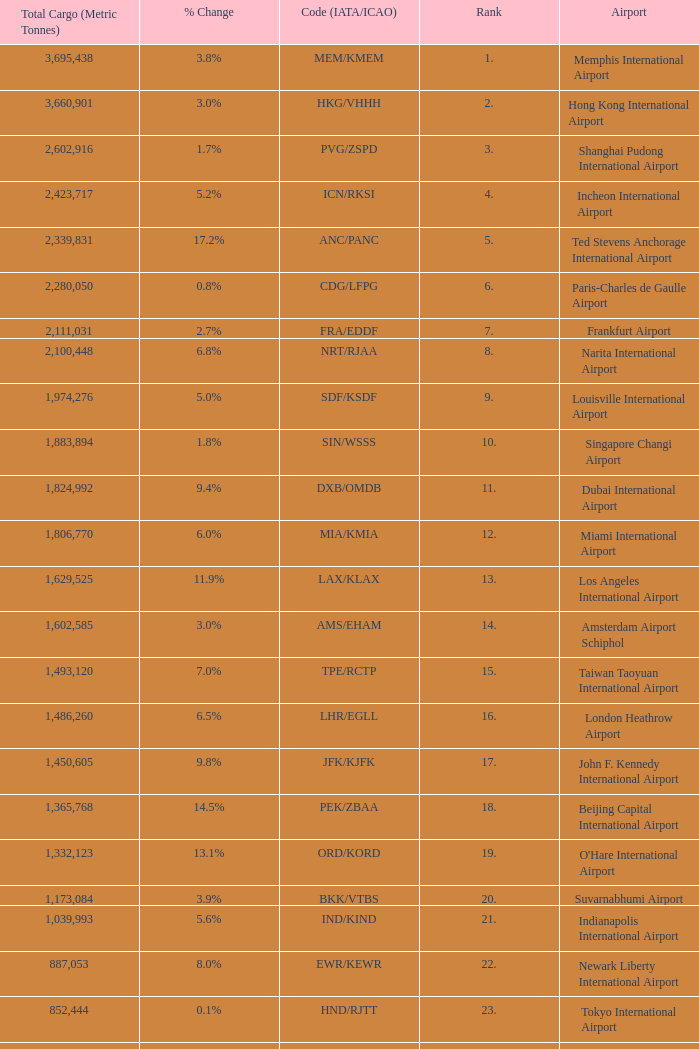What is the code for rank 10? SIN/WSSS. 